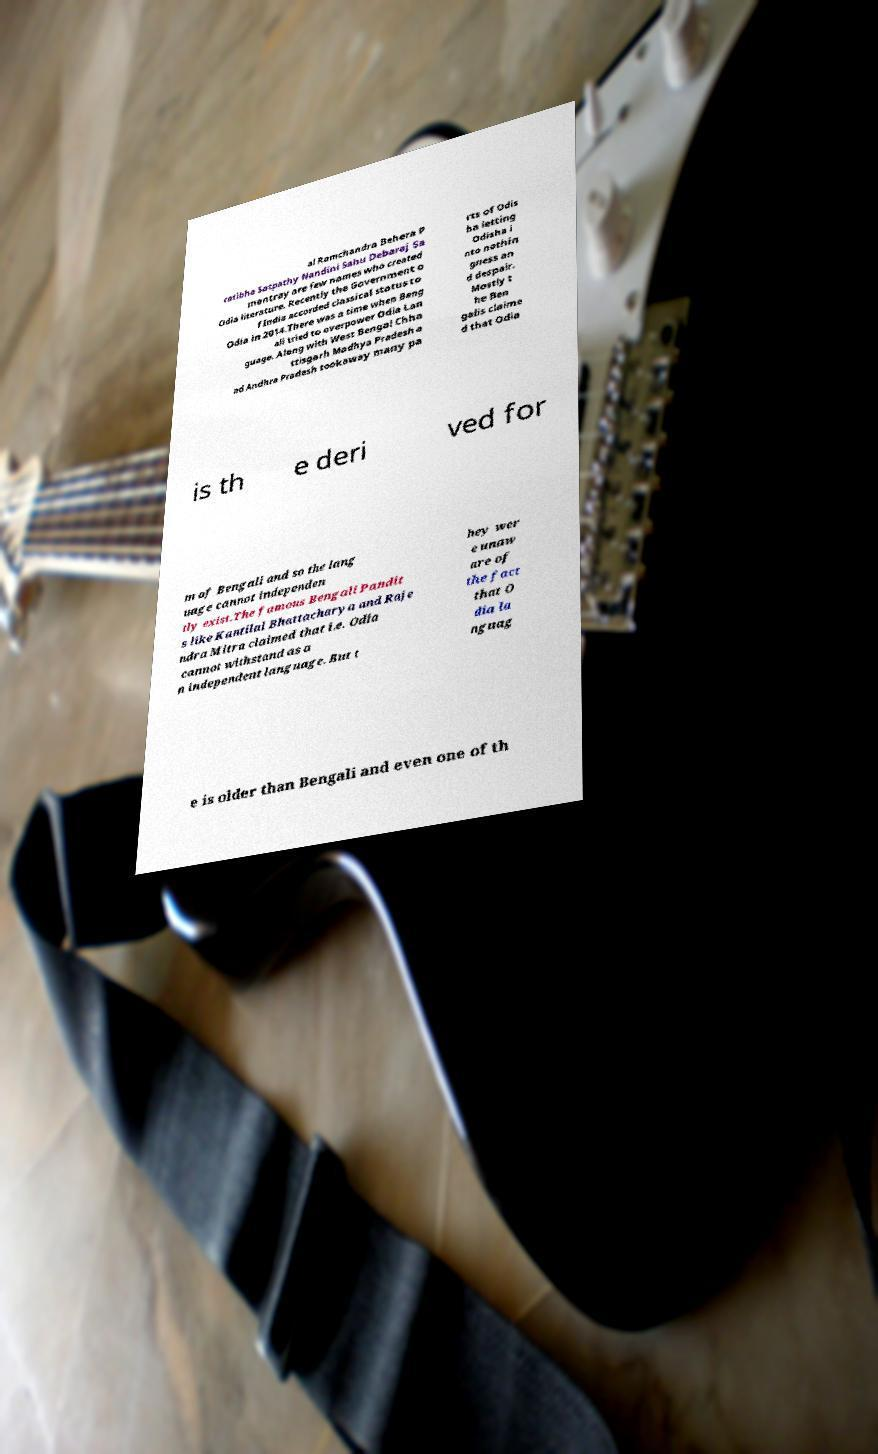For documentation purposes, I need the text within this image transcribed. Could you provide that? al Ramchandra Behera P ratibha Satpathy Nandini Sahu Debaraj Sa mantray are few names who created Odia literature. Recently the Government o f India accorded classical status to Odia in 2014.There was a time when Beng ali tried to overpower Odia Lan guage. Along with West Bengal Chha ttisgarh Madhya Pradesh a nd Andhra Pradesh tookaway many pa rts of Odis ha letting Odisha i nto nothin gness an d despair. Mostly t he Ben galis claime d that Odia is th e deri ved for m of Bengali and so the lang uage cannot independen tly exist.The famous Bengali Pandit s like Kantilal Bhattacharya and Raje ndra Mitra claimed that i.e. Odia cannot withstand as a n independent language. But t hey wer e unaw are of the fact that O dia la nguag e is older than Bengali and even one of th 